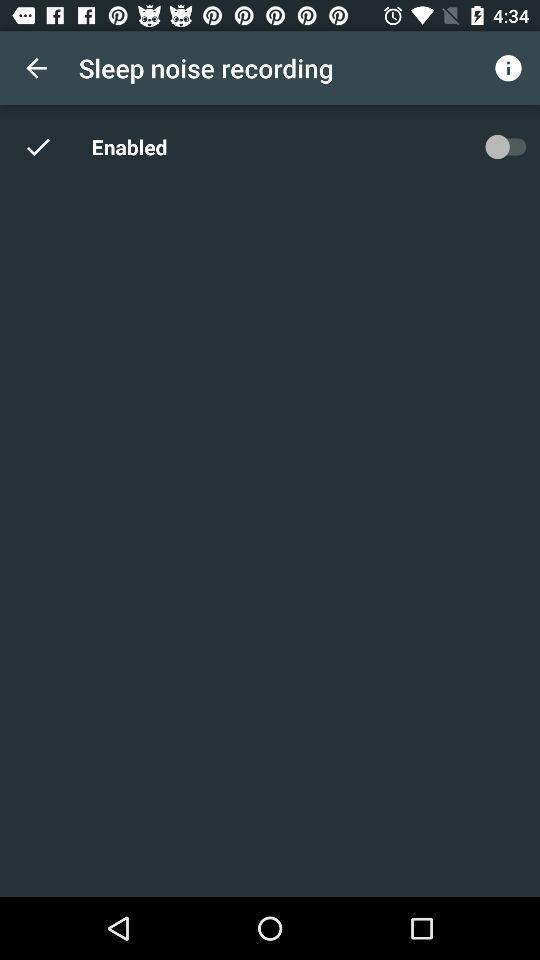How long is the recording?
When the provided information is insufficient, respond with <no answer>. <no answer> 